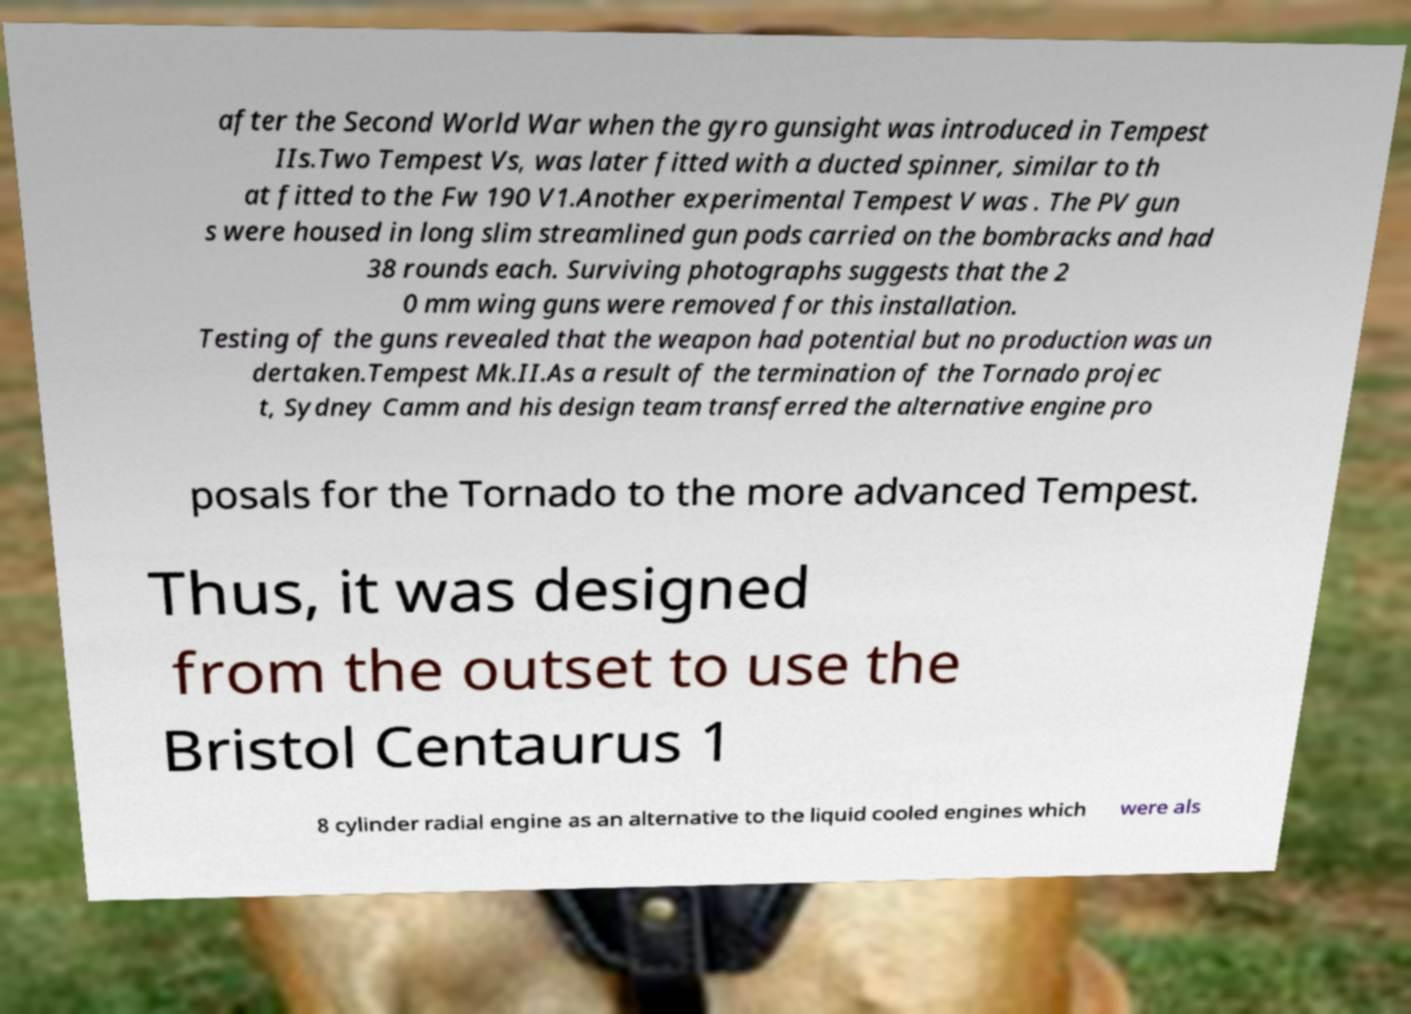Could you extract and type out the text from this image? after the Second World War when the gyro gunsight was introduced in Tempest IIs.Two Tempest Vs, was later fitted with a ducted spinner, similar to th at fitted to the Fw 190 V1.Another experimental Tempest V was . The PV gun s were housed in long slim streamlined gun pods carried on the bombracks and had 38 rounds each. Surviving photographs suggests that the 2 0 mm wing guns were removed for this installation. Testing of the guns revealed that the weapon had potential but no production was un dertaken.Tempest Mk.II.As a result of the termination of the Tornado projec t, Sydney Camm and his design team transferred the alternative engine pro posals for the Tornado to the more advanced Tempest. Thus, it was designed from the outset to use the Bristol Centaurus 1 8 cylinder radial engine as an alternative to the liquid cooled engines which were als 